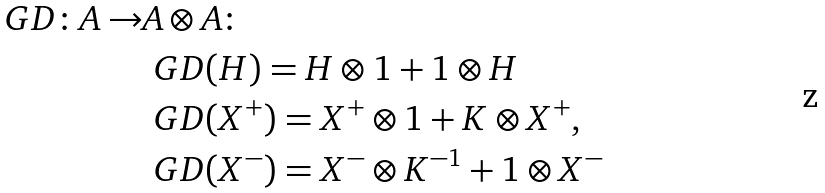<formula> <loc_0><loc_0><loc_500><loc_500>\ G D \colon A \to & A \otimes A \colon \\ & \ G D ( H ) = H \otimes 1 + 1 \otimes H \\ & \ G D ( X ^ { + } ) = X ^ { + } \otimes 1 + K \otimes X ^ { + } , \\ & \ G D ( X ^ { - } ) = X ^ { - } \otimes K ^ { - 1 } + 1 \otimes X ^ { - }</formula> 